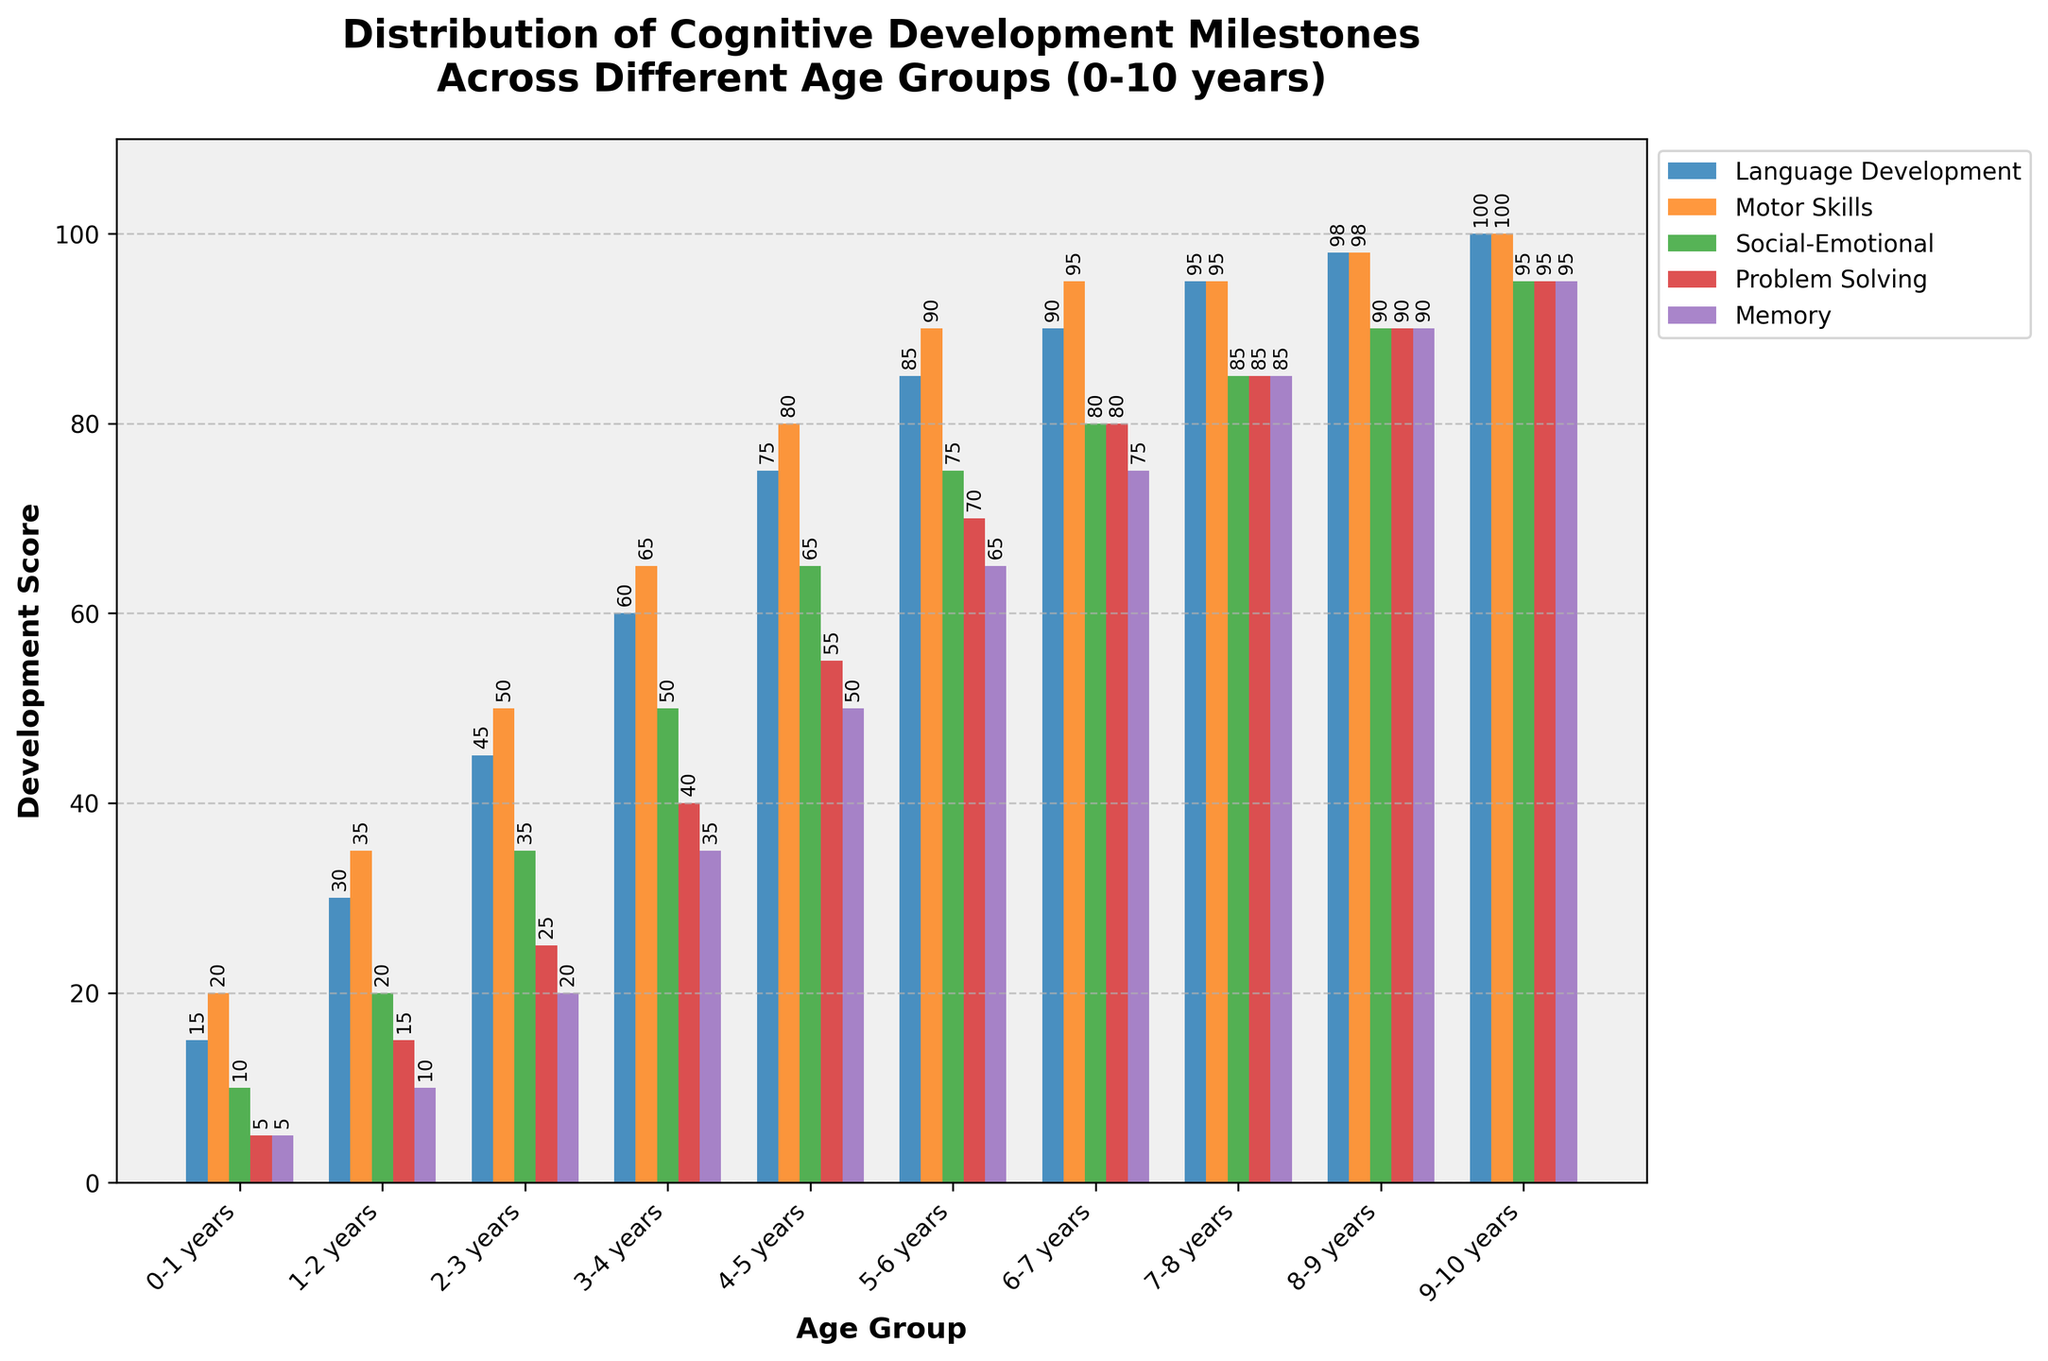Which age group has the highest score in motor skills? Observe the bar labeled "Motor Skills" and compare the heights across all age groups. The highest bar is for the age group of 9-10 years.
Answer: 9-10 years Which age group shows the largest increase in problem-solving skills compared to the previous age group? Compare the differences in the "Problem Solving" bars between consecutive age groups. The largest increase is from the 5-6 years group (70) to the 6-7 years group (80).
Answer: 6-7 years What's the total development score across all categories for the 7-8 years age group? Add the values for each category for the 7-8 years age group. Calculation: 95 (Language Development) + 95 (Motor Skills) + 85 (Social-Emotional) + 85 (Problem Solving) + 85 (Memory) = 445.
Answer: 445 In which age group does memory development reach 50? Look for the "Memory" bar that reaches the value of 50, which corresponds to the 4-5 years age group.
Answer: 4-5 years At what age group do all categories achieve their peak scores? Examine the highest and final bars of each development category; all reach their peak scores in the 9-10 years age group.
Answer: 9-10 years Comparing social-emotional development, which is the greater difference: from 0-1 years to 3-4 years or from 4-5 years to 7-8 years? Calculate the differences: (3-4) - (0-1) = 50 - 10 = 40 and (7-8) - (4-5) = 85 - 65 = 20. The greater difference is between 0-1 years and 3-4 years.
Answer: From 0-1 years to 3-4 years Which age group shows the first instance of achieving over 90 in motor skills? Find the "Motor Skills" bar that first surpasses 90. This occurs at the 6-7 years age group.
Answer: 6-7 years Between which two age groups does language development show the smallest change? Compare the differences in "Language Development" scores between consecutive age groups. The smallest change occurs between 7-8 years (95) and 8-9 years (98), a difference of 3.
Answer: 7-8 years to 8-9 years For the 5-6 years age group, what is the average score across all categories? Calculate the average for the 5-6 years age group: (85 + 90 + 75 + 70 + 65) / 5 = 77.
Answer: 77 At what age do children have a significantly balanced score (almost equal) across all milestones? Look for the age group where the scores for all categories are close to each other. The 9-10 years age group is the most balanced, with scores around 95 in all categories.
Answer: 9-10 years 